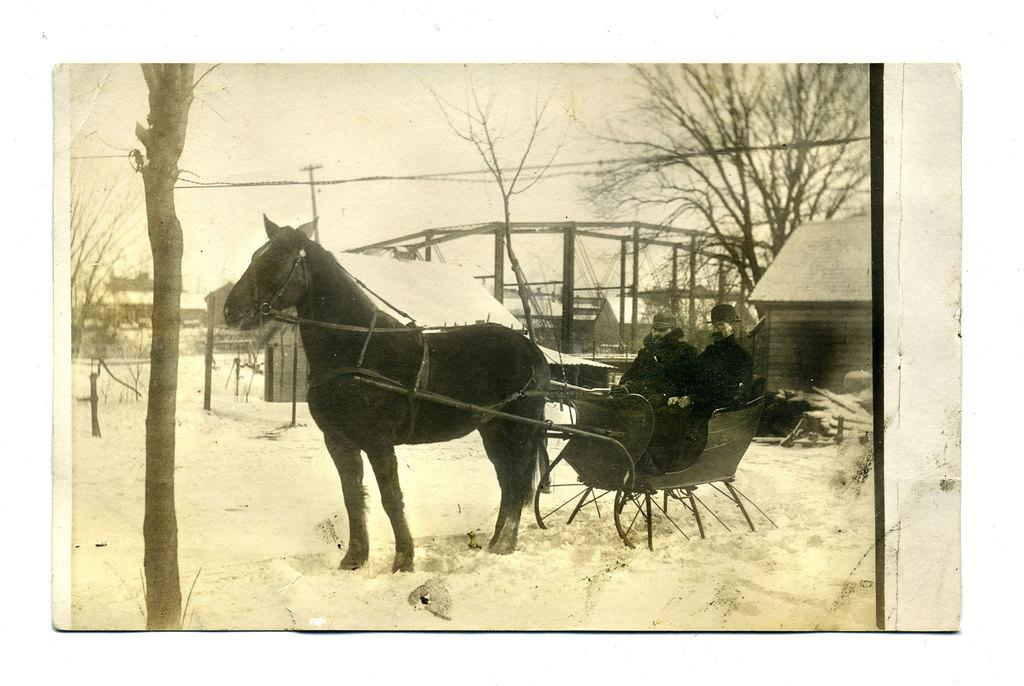What type of picture is the image? The image is an old black and white picture. What is the weather condition in the image? There is snow in the image. What animal is present in the image? There is a horse in the image. What are the two persons doing in the image? Two persons are sitting on a horse cart. What type of structures can be seen in the image? There are houses in the image. What type of vegetation is present in the image? There are trees in the image. What is visible in the background of the image? The sky is visible in the background of the image. Where can the coal be found in the image? There is no coal present in the image. What type of fingerprint can be seen on the horse's back? There is no fingerprint visible on the horse's back in the image. 